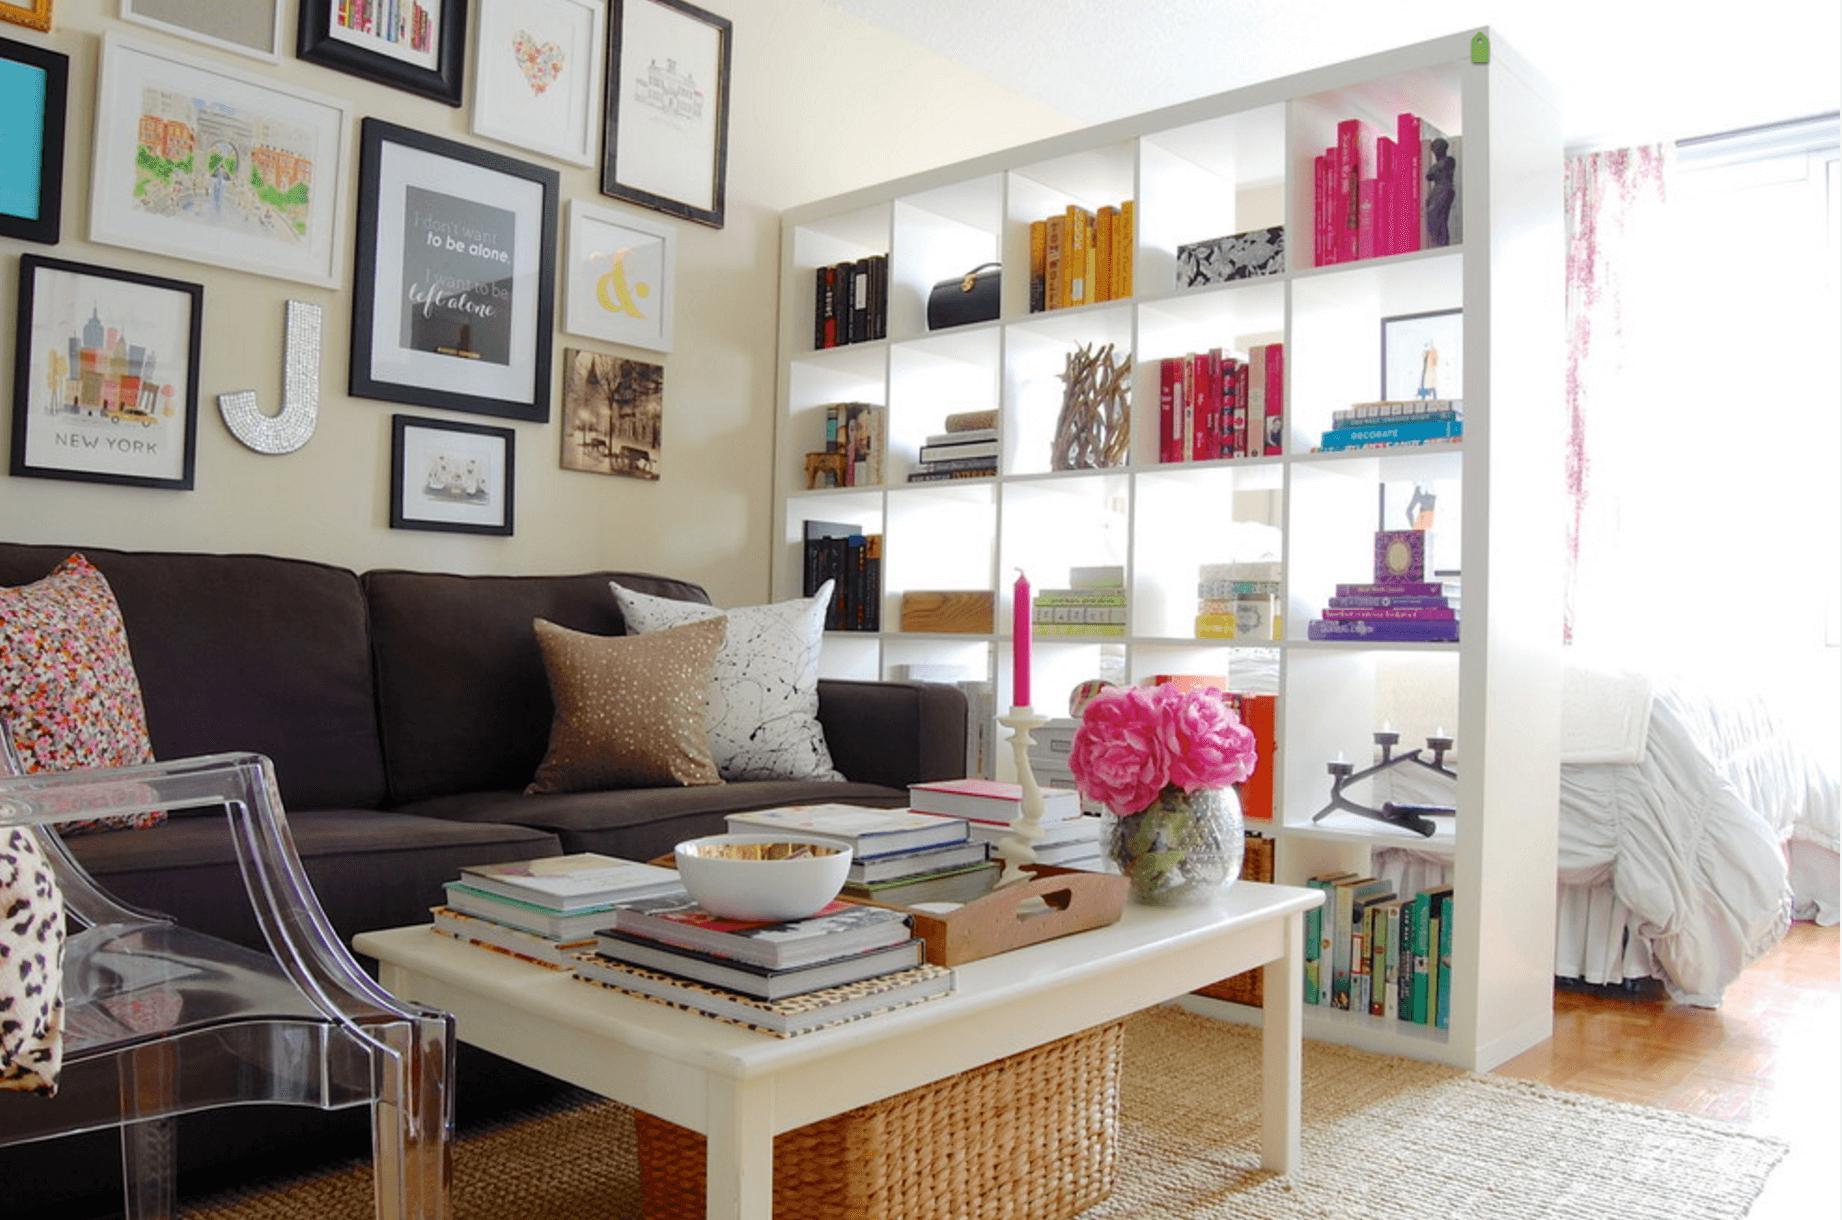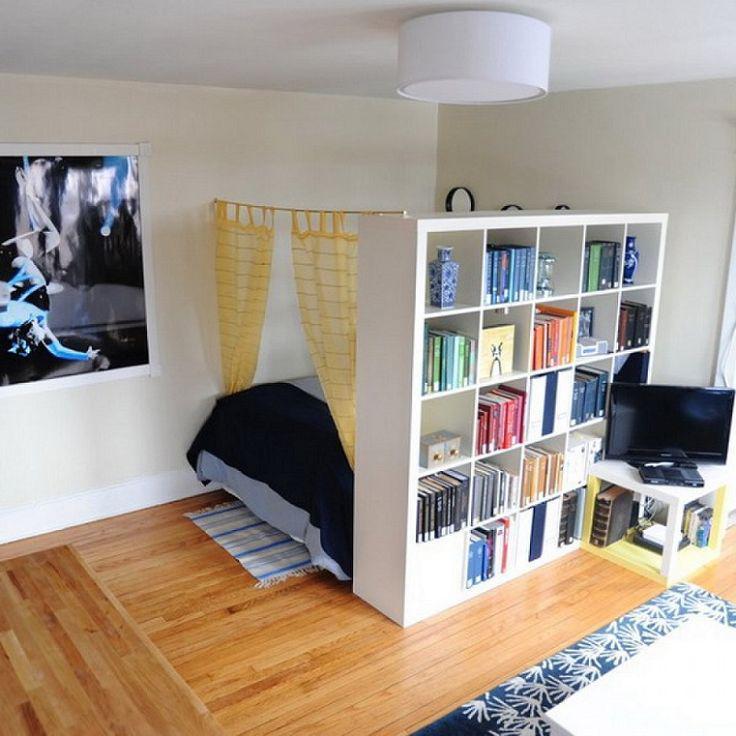The first image is the image on the left, the second image is the image on the right. Examine the images to the left and right. Is the description "In at least one image, there's a white shelf blocking a bed from view." accurate? Answer yes or no. Yes. 